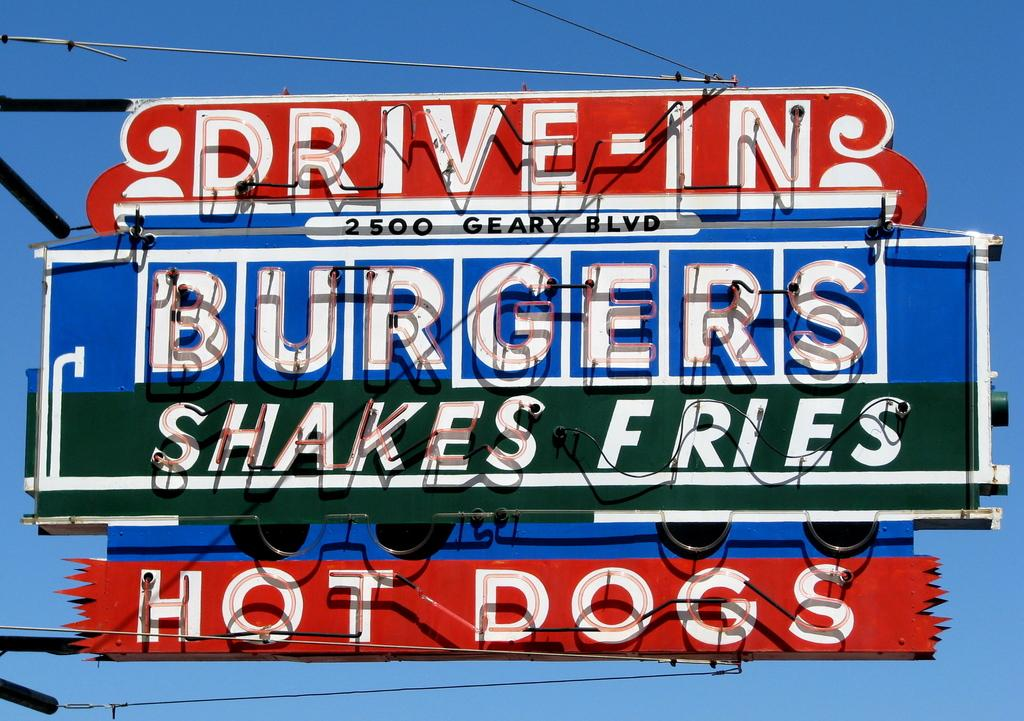<image>
Summarize the visual content of the image. An outdoor sign with the words Drive In Burgers on it. 